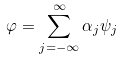Convert formula to latex. <formula><loc_0><loc_0><loc_500><loc_500>\varphi = \sum _ { j = - \infty } ^ { \infty } \alpha _ { j } \psi _ { j }</formula> 